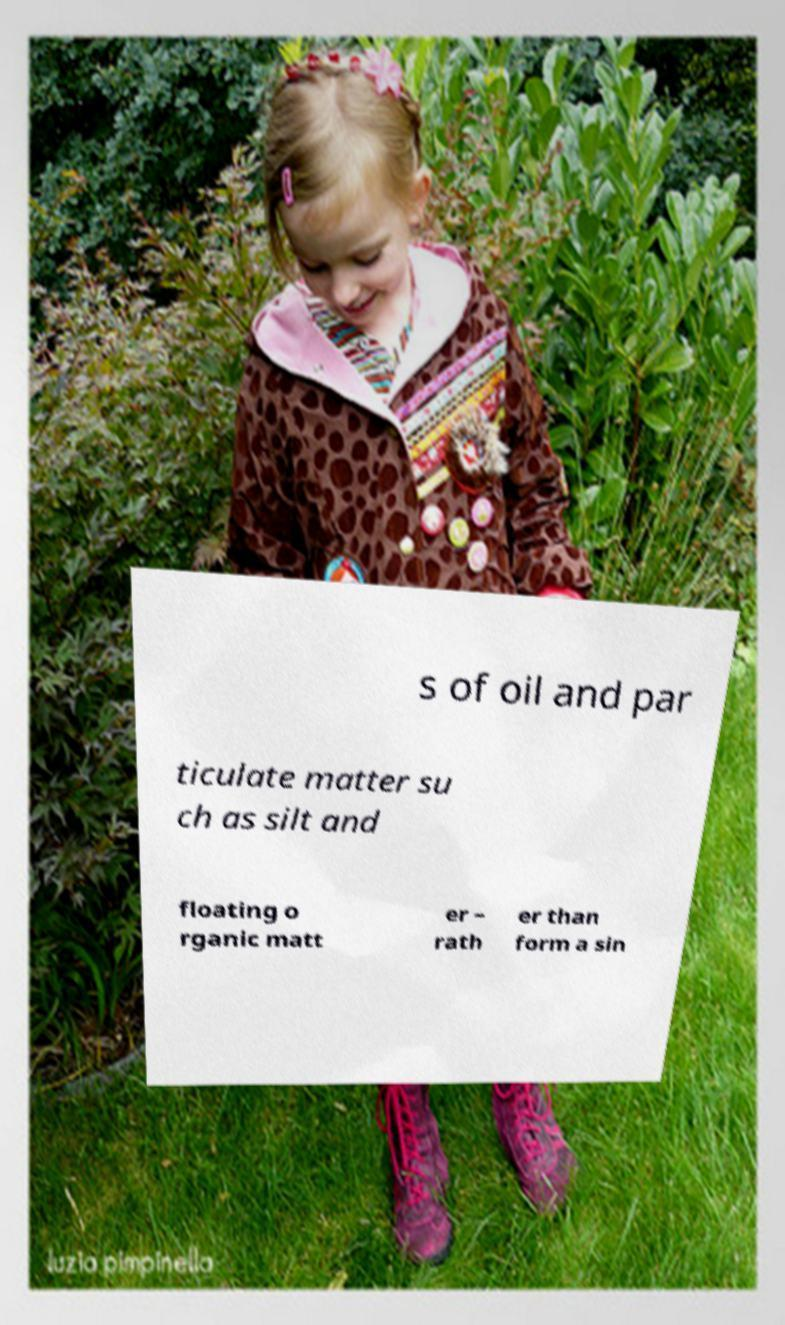Please read and relay the text visible in this image. What does it say? s of oil and par ticulate matter su ch as silt and floating o rganic matt er – rath er than form a sin 